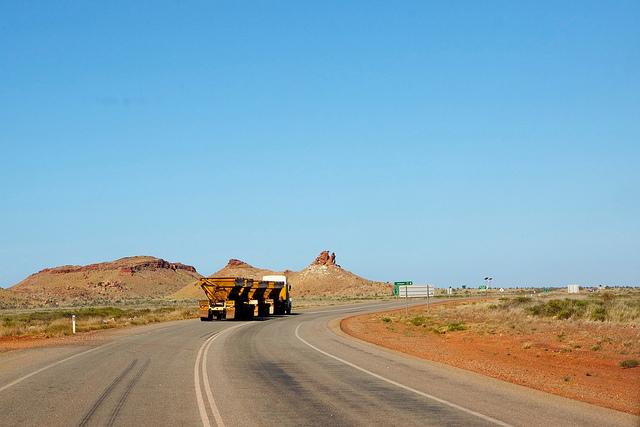Are there any cars on the road?
Quick response, please. No. Is there an animal in front of the vehicle?
Keep it brief. No. Could a basketball team fit in this vehicle?
Short answer required. No. Is this a mountainous terrain?
Give a very brief answer. Yes. Is it sunny?
Answer briefly. Yes. Is this a tour bus?
Give a very brief answer. No. 